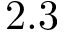<formula> <loc_0><loc_0><loc_500><loc_500>2 . 3</formula> 